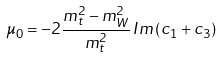Convert formula to latex. <formula><loc_0><loc_0><loc_500><loc_500>\mu _ { 0 } = - 2 \frac { m _ { t } ^ { 2 } - m _ { W } ^ { 2 } } { m _ { t } ^ { 2 } } \, I m \left ( c _ { 1 } + c _ { 3 } \right )</formula> 